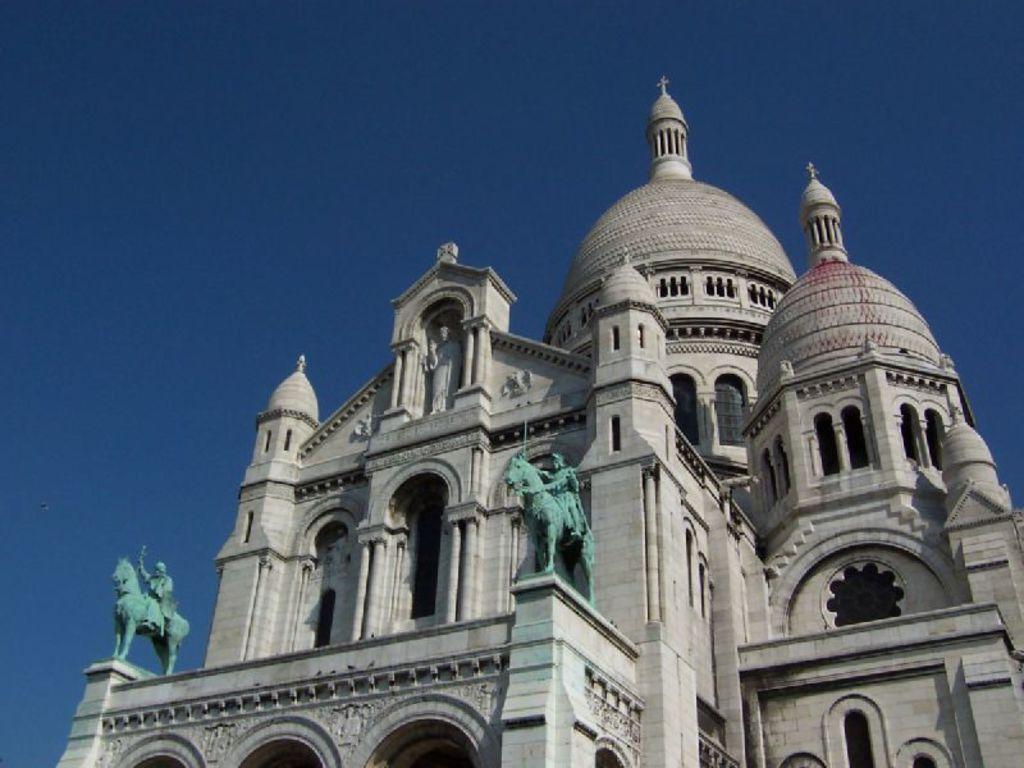Please provide a concise description of this image. In this image we can see a building with arches and pillars. On the building there are statues. In the background there is sky. 